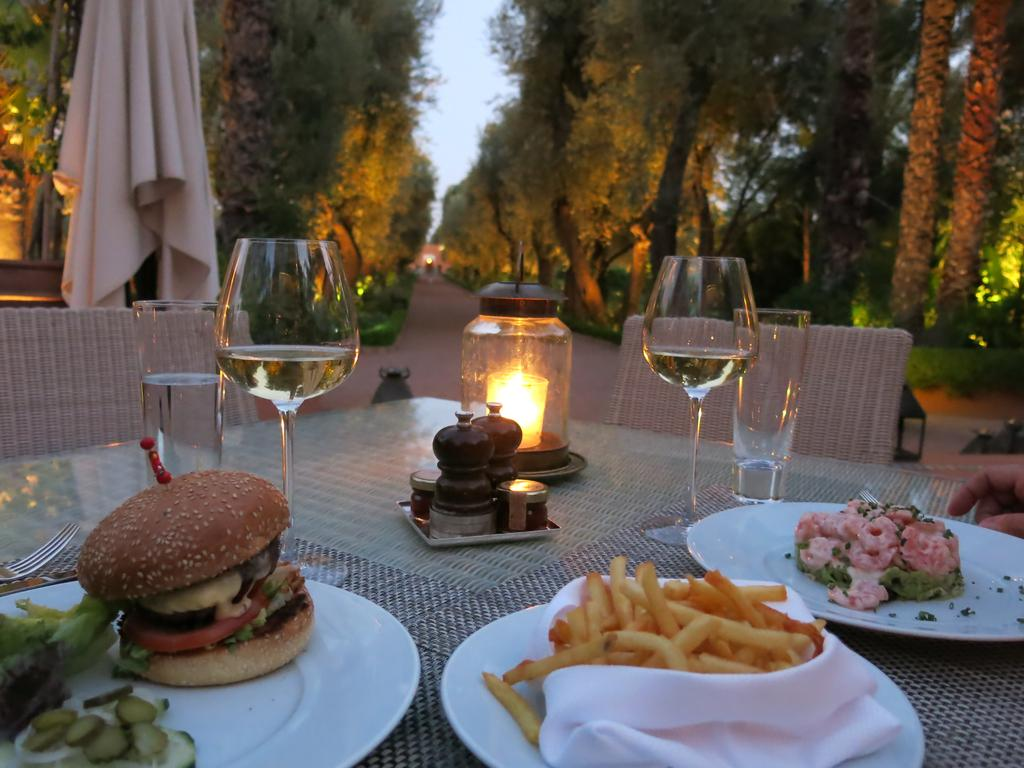What type of furniture is present in the image? There is a table in the image. What items can be seen on the table? There are plates, glasses, a candle, and food on the table. Are there any seating options near the table? Yes, there are chairs near the table. What can be seen in the background of the image? Trees, a road, and the sky are visible in the image. What type of material is present on the table? There is a cloth on the table. Can you tell me what type of alarm is ringing in the image? There is no alarm present in the image. What kind of bottle can be seen on the table in the image? There is no bottle visible on the table in the image. 